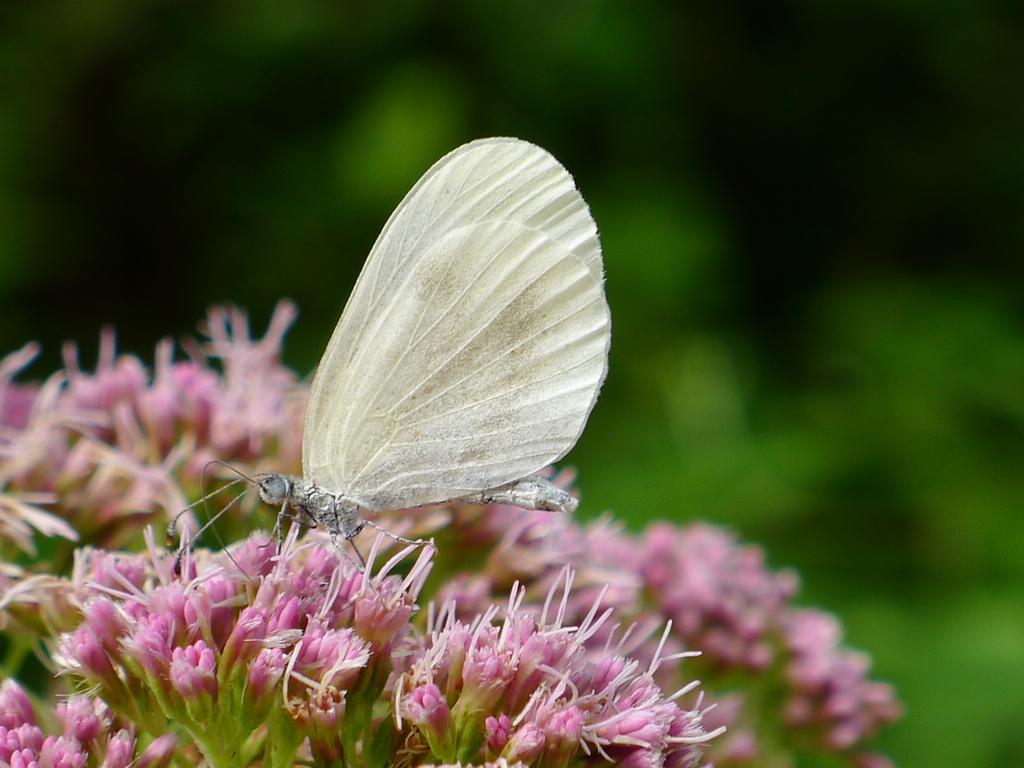What is present on the flowers in the image? There is an insect on the flowers in the image. What type of vegetation can be seen in the background of the image? There are flowers visible in the background of the image. How would you describe the clarity of the image? The image is blurry, but objects can still be seen. What type of ear is visible on the insect in the image? There is no ear visible on the insect in the image, as insects do not have ears like humans. What class is the insect attending in the image? Insects do not attend classes, as they are not capable of human-like learning and education. 